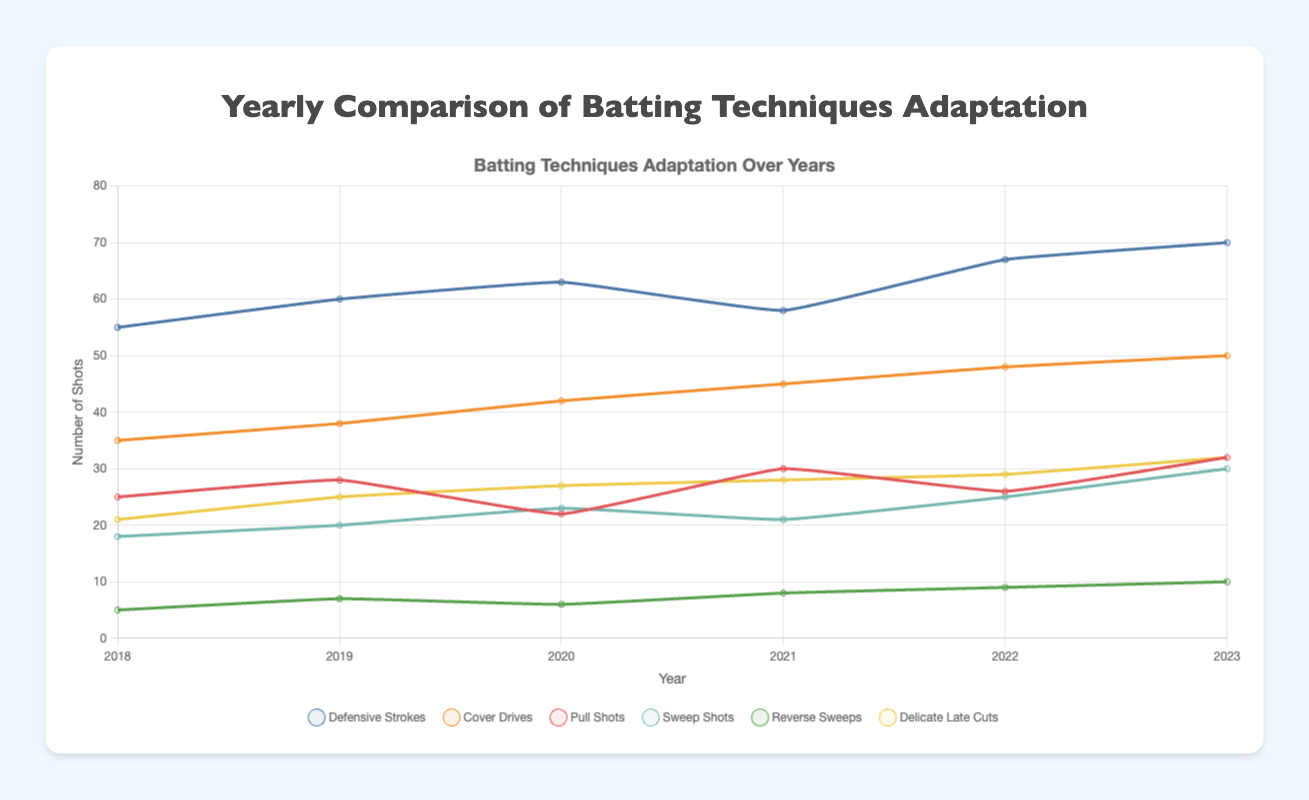What's the sum of all delicate late cuts played against spin bowlers from 2018 to 2023? The number of delicate late cuts played each year from 2018 to 2023 are as follows: 21, 25, 27, 28, 29, and 32. Summing these numbers gives 21 + 25 + 27 + 28 + 29 + 32 = 162.
Answer: 162 Which year showed the highest number of cover drives against fast bowlers? Looking at the cover drives against fast bowlers from 2018 to 2023, the numbers are as follows: 35, 38, 42, 45, 48, and 50. The highest value is 50, which occurred in 2023.
Answer: 2023 How did the number of defensive strokes against fast bowlers change from 2018 to 2023? The number of defensive strokes from 2018 to 2023 are as follows: 55, 60, 63, 58, 67, and 70. From 2018 to 2023, the defensive strokes generally increased, with a slight dip in 2021, before reaching the peak at 70 in 2023.
Answer: Increased What is the average number of pull shots played against fast bowlers over the years? The number of pull shots from 2018 to 2023 are 25, 28, 22, 30, 26, and 32. The sum is 25 + 28 + 22 + 30 + 26 + 32 = 163. Dividing the sum by 6 gives the average as 163 / 6 ≈ 27.17.
Answer: 27.17 Compare the trend of sweep shots against spin bowlers and cover drives against fast bowlers from 2018 to 2023. For sweep shots, the numbers from 2018 to 2023 are 18, 20, 23, 21, 25, and 30, showing an upward trend. For cover drives, the numbers are 35, 38, 42, 45, 48, and 50, also showing an upward trend. Both trends indicate an increase, but cover drives had a higher starting point and a more consistent increase.
Answer: Both increased Which type of shot shows the maximum increase against fast bowlers from 2018 to 2023? The increases for each type of shot from 2018 to 2023 are calculated as follows: Defensive strokes (70-55 = 15), cover drives (50-35 = 15), and pull shots (32-25 = 7). Both defensive strokes and cover drives have the maximum increase of 15.
Answer: Defensive Strokes and Cover Drives What was the difference between the number of reverse sweeps played in 2018 and 2023? The number of reverse sweeps in 2018 was 5, and in 2023 it was 10. The difference is 10 - 5 = 5.
Answer: 5 From 2018 to 2023, which year saw the lowest number of sweep shots against spin bowlers? The number of sweep shots from 2018 to 2023 are 18, 20, 23, 21, 25, and 30. The lowest value is 18, which occurred in 2018.
Answer: 2018 